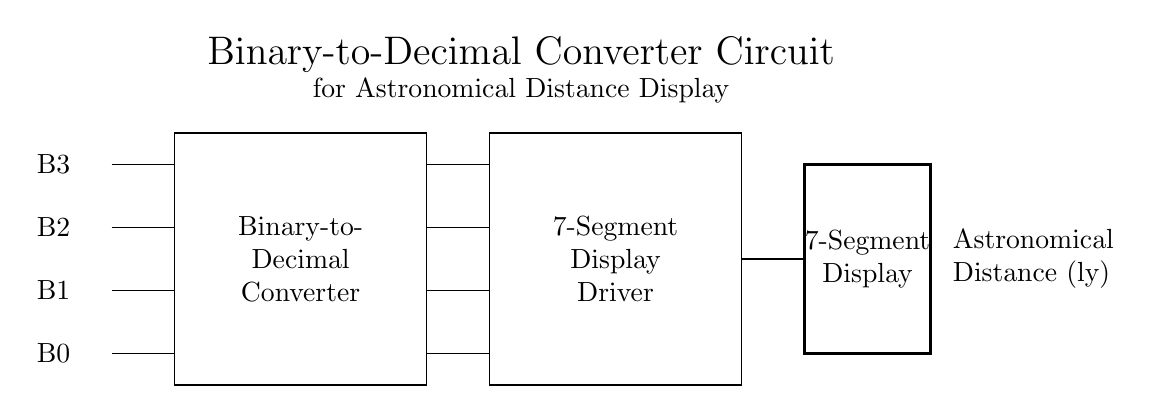What are the inputs of the binary-to-decimal converter? The inputs are labeled B3, B2, B1, and B0 in the circuit, indicating they are the binary values that will be converted.
Answer: B3, B2, B1, B0 What does the rectangle labeled "Binary-to-Decimal Converter" represent? This rectangle denotes the main component that takes the binary inputs and converts them into decimal values for further processing.
Answer: Binary-to-Decimal Converter How many segments does the 7-segment display have? A standard 7-segment display consists of seven segments that can light up to display decimal digits.
Answer: Seven What is the output of the binary-to-decimal converter? The output lines directly connect to the 7-segment display driver, indicating that the converted decimal values will be sent there for visual representation.
Answer: Decimal values What is the purpose of the 7-segment display in this circuit? The 7-segment display visually represents the output from the binary-to-decimal converter, showing astronomical distances in a readable format.
Answer: To display distances If the binary input is 1010, what decimal number would the binary-to-decimal converter produce? The binary number 1010 converts to decimal 10, as it represents one eight and one two.
Answer: Ten Which component drives the display after conversion? The component tasked with driving the display is labeled "7-Segment Display Driver," as it connects the converted outputs to the display.
Answer: 7-Segment Display Driver 